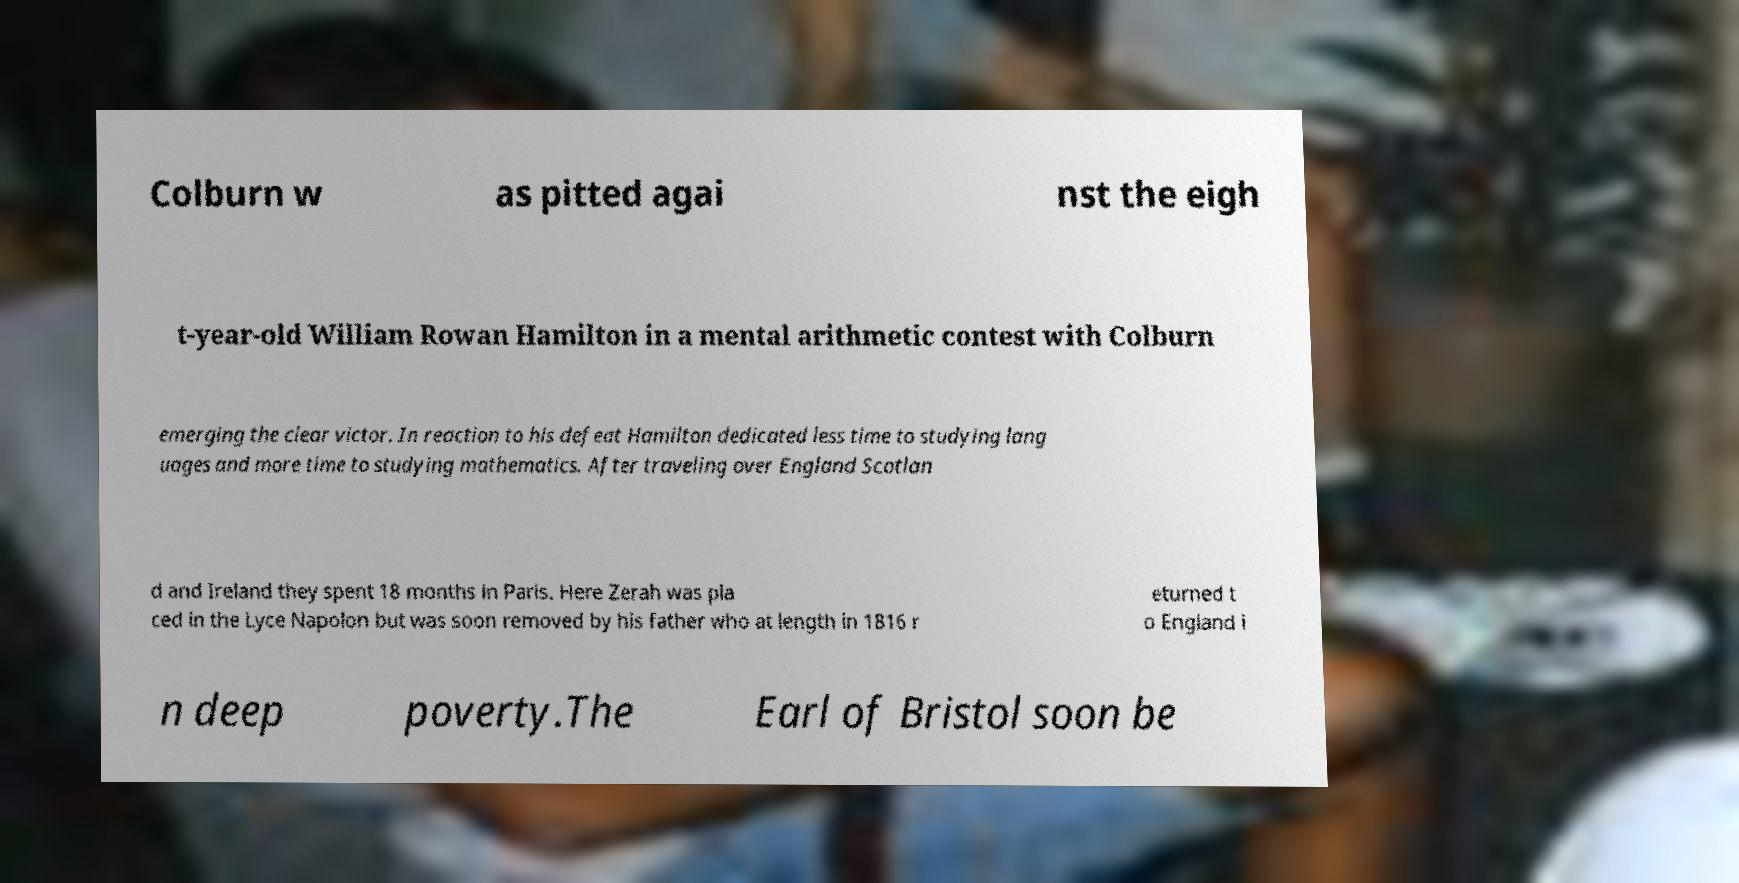I need the written content from this picture converted into text. Can you do that? Colburn w as pitted agai nst the eigh t-year-old William Rowan Hamilton in a mental arithmetic contest with Colburn emerging the clear victor. In reaction to his defeat Hamilton dedicated less time to studying lang uages and more time to studying mathematics. After traveling over England Scotlan d and Ireland they spent 18 months in Paris. Here Zerah was pla ced in the Lyce Napolon but was soon removed by his father who at length in 1816 r eturned t o England i n deep poverty.The Earl of Bristol soon be 